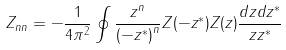Convert formula to latex. <formula><loc_0><loc_0><loc_500><loc_500>Z _ { n n } = - \frac { 1 } { 4 \pi ^ { 2 } } \oint \frac { z ^ { n } } { { ( - z ^ { * } ) } ^ { n } } Z ( - z ^ { * } ) Z ( z ) \frac { d z d z ^ { * } } { z z ^ { * } }</formula> 